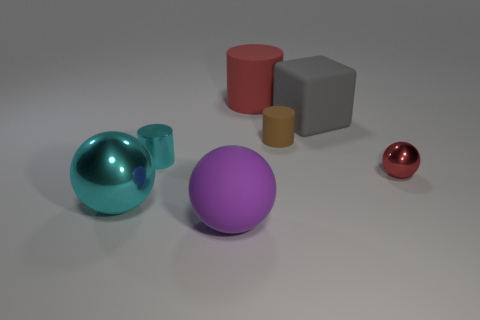Add 2 big purple things. How many objects exist? 9 Subtract all cylinders. How many objects are left? 4 Subtract 0 brown balls. How many objects are left? 7 Subtract all purple matte spheres. Subtract all big gray rubber blocks. How many objects are left? 5 Add 3 big metal balls. How many big metal balls are left? 4 Add 4 tiny cylinders. How many tiny cylinders exist? 6 